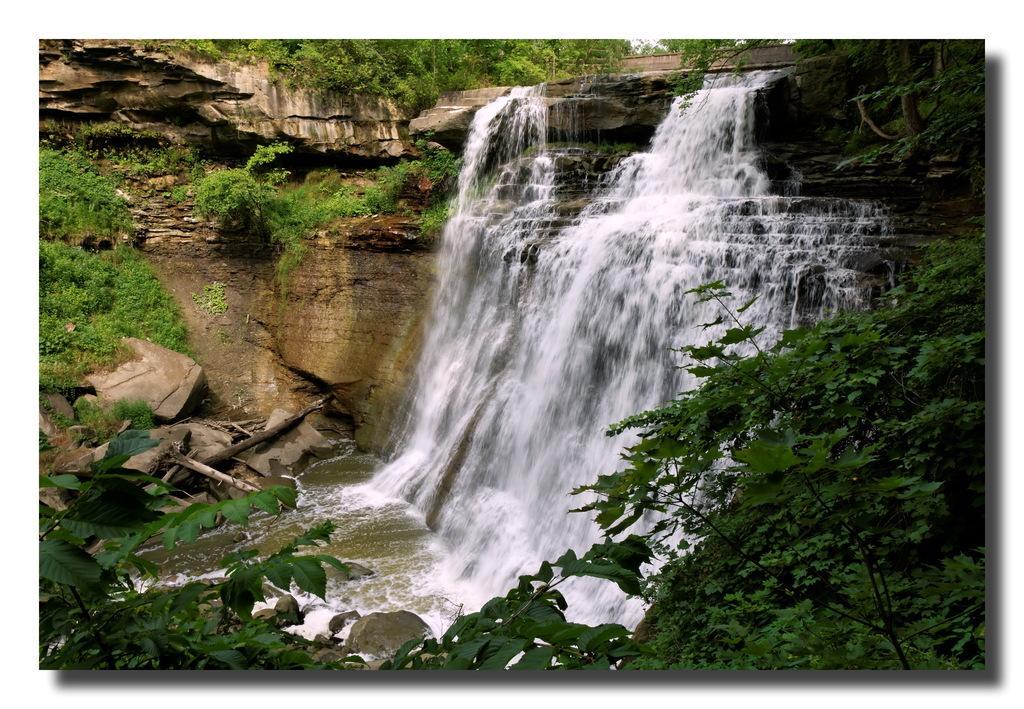Please provide a concise description of this image. In this image we can see waterfall and plants. 